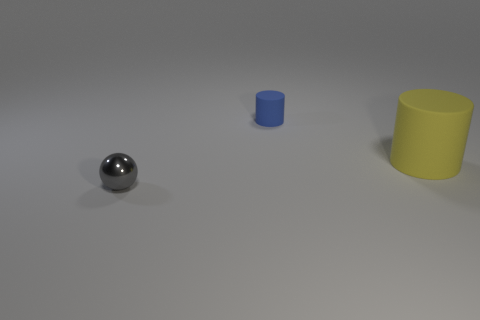Add 3 small metal objects. How many objects exist? 6 Subtract all cylinders. How many objects are left? 1 Add 3 yellow matte cylinders. How many yellow matte cylinders exist? 4 Subtract 0 blue balls. How many objects are left? 3 Subtract all blue rubber cylinders. Subtract all gray shiny objects. How many objects are left? 1 Add 1 tiny rubber things. How many tiny rubber things are left? 2 